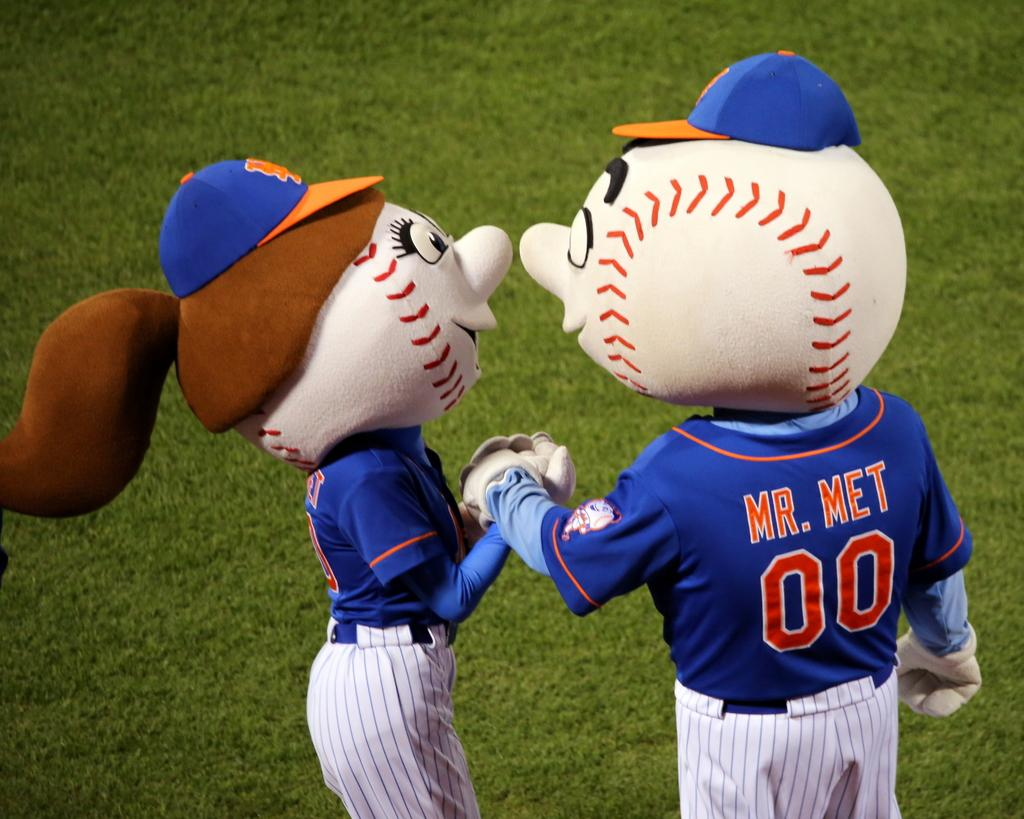Provide a one-sentence caption for the provided image. A girl and boy mascot for the Mets baseball team. 